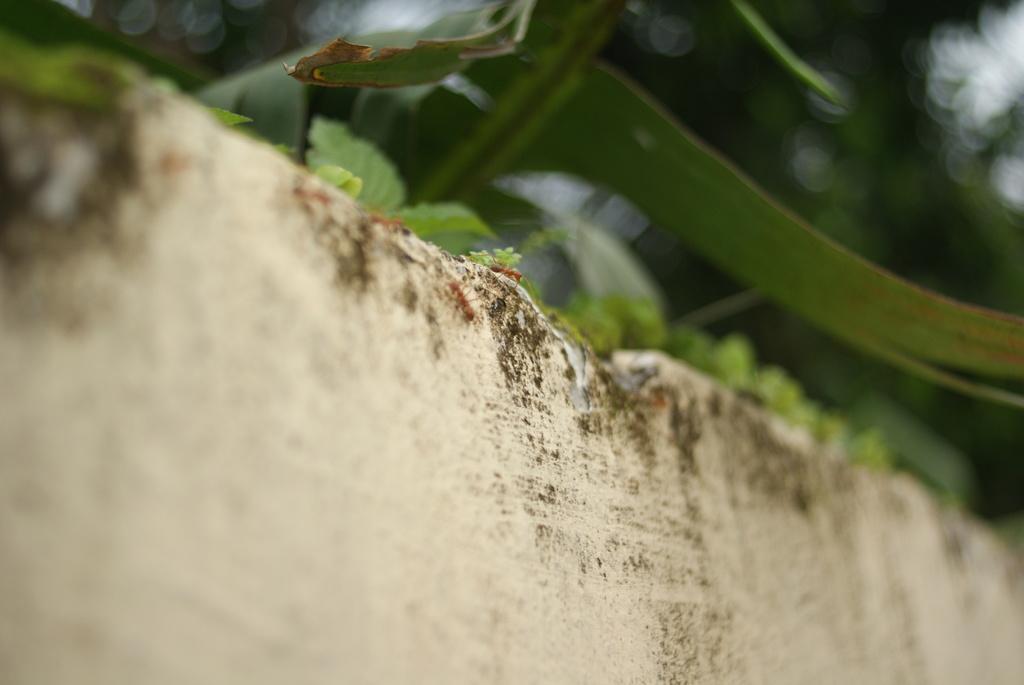How would you summarize this image in a sentence or two? At the bottom of this image I can see a wall. On this I can see few ants. On the top of the image few leaves are visible. 